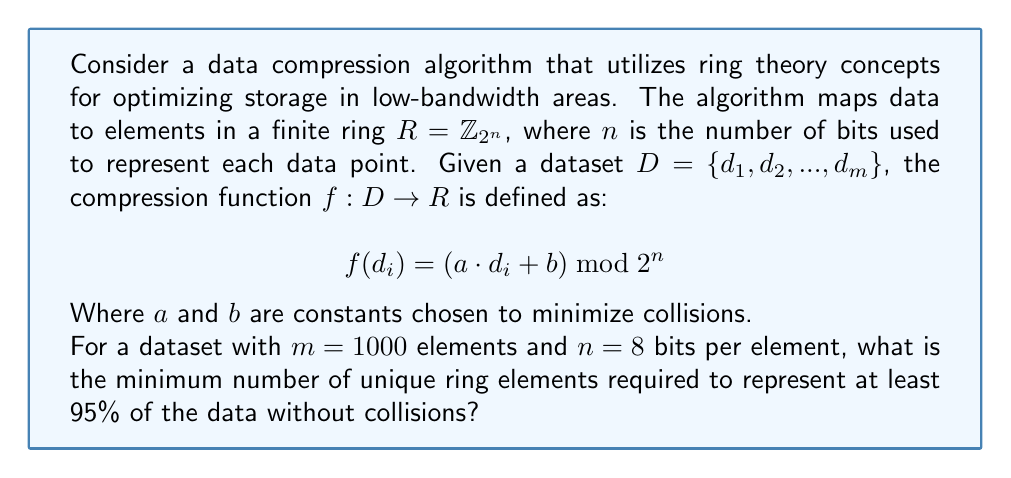Could you help me with this problem? To solve this problem, we need to follow these steps:

1) First, we need to understand what the question is asking. We're looking for the minimum number of unique elements in the ring that can represent 95% of our data without collisions.

2) The total number of elements in our dataset is $m = 1000$.

3) We want to represent at least 95% of this data, so we need to calculate 95% of 1000:
   
   $1000 \cdot 0.95 = 950$

4) This means we need at least 950 unique elements in our ring to represent 95% of the data without collisions.

5) Now, let's consider the ring $R = \mathbb{Z}_{2^n}$. With $n = 8$, we have:

   $R = \mathbb{Z}_{2^8} = \mathbb{Z}_{256}$

6) This ring has 256 elements in total, which is less than the 950 we need.

7) To find the minimum $n$ that gives us at least 950 elements, we need to solve:

   $2^n \geq 950$

8) Taking the logarithm of both sides:

   $n \cdot \log_2(2) \geq \log_2(950)$
   $n \geq \log_2(950) \approx 9.89$

9) Since $n$ must be an integer, we round up to the nearest whole number:

   $n = 10$

10) Therefore, we need a ring $R = \mathbb{Z}_{2^{10}} = \mathbb{Z}_{1024}$, which has 1024 elements.
Answer: 1024 